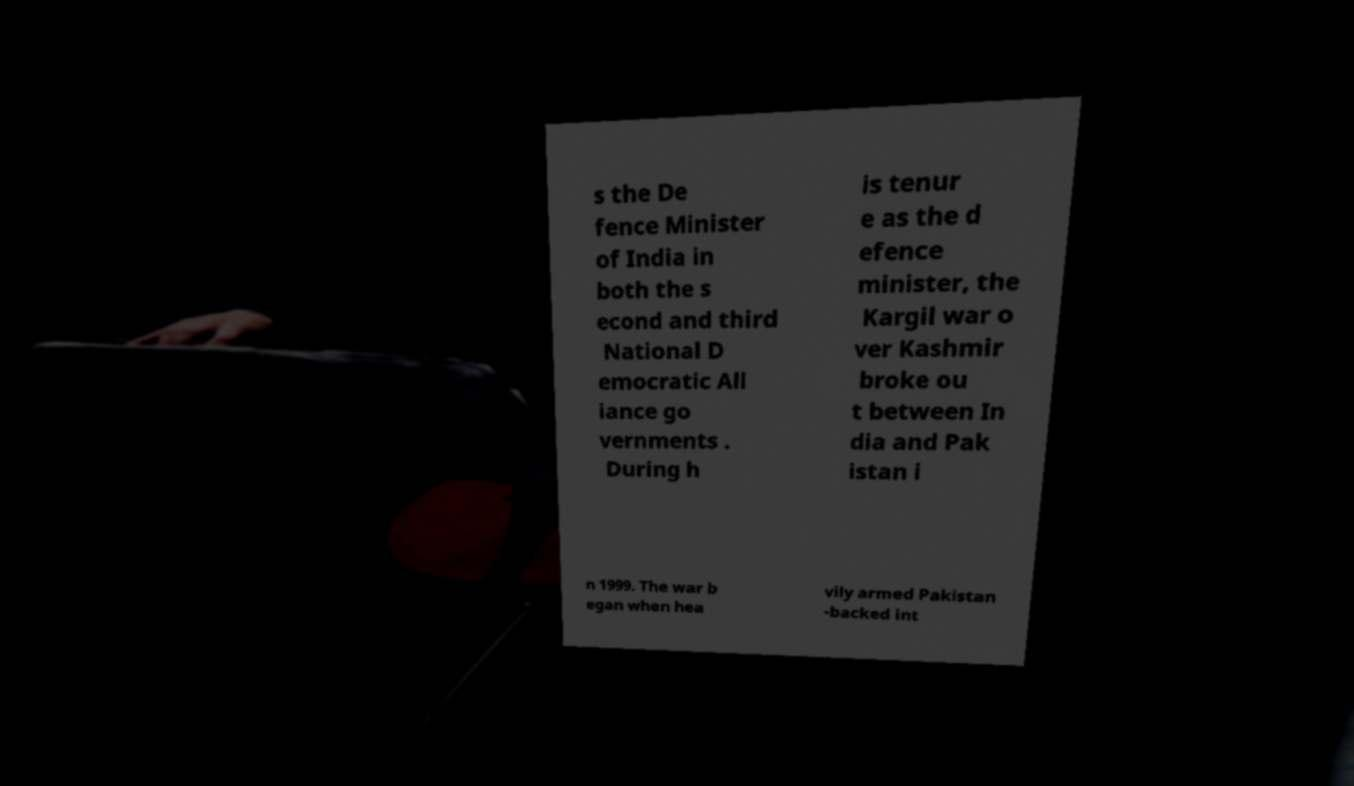Could you assist in decoding the text presented in this image and type it out clearly? s the De fence Minister of India in both the s econd and third National D emocratic All iance go vernments . During h is tenur e as the d efence minister, the Kargil war o ver Kashmir broke ou t between In dia and Pak istan i n 1999. The war b egan when hea vily armed Pakistan -backed int 